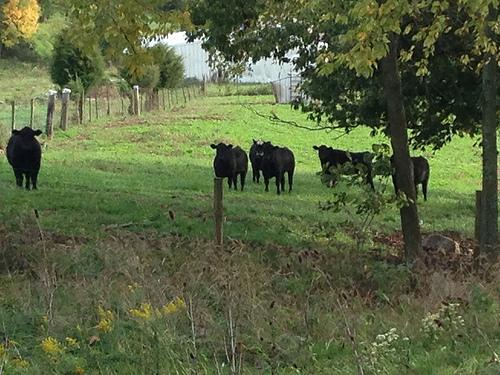Identify the types of plants and flowers seen in the image. There are yellow and white flowers, weeds, and a tree with yellow leaves in the grassy field, as well as a branch with no leaves and a tall tree trunk. Write a description of the image while emphasizing the presence of one of the objects for a referential expression grounding task. This serene image captures a moment in a peaceful field, where a group of cattle is thriving under the gentle shade of two trees, one of which is particularly striking with its yellow leaves reaching out over the scene. What animals can be seen in the image and what are they doing? Several cows, mostly black angus, are standing around in a green grassy field, with some looking up or standing alone. What specific characteristics were mentioned about the cows in the image? Some cows have white spots on their heads, ear sticking out or an ear can be seen, and one cow has four legs visible. Select a random object or part of the scene and describe it in detail. There is a rock on the ground between two trees, which is described as a piece of rock on the ground, approximately 22 by 22 pixels in size. Briefly describe the environment and structures present in the image. The image shows a grassy field with cows, a fence with wooden posts, a large white building, two trees shading the cows, and a hill on the left of the field. Describe the scene as if you were creating an advertisement to sell the property. Enjoy idyllic country living on this picturesque property featuring a large white building, a lush green grassy field filled with healthy cows, and stunning natural surroundings including trees, flowers, and charming wooden fences. Describe the fence and any related objects in the image. There is a wooden fence with posts bounding the field, with a fence behind some cows, at the edge of the field, and a wooden post in the ground. Identify any points of interest or unique aspects of the image overall. The grass is going to seed, there is a whitish surface in the background, and there are dried-up plants among the grass. Based on the image's content, formulate a "true or false" question for a VQA task. Answer: True 